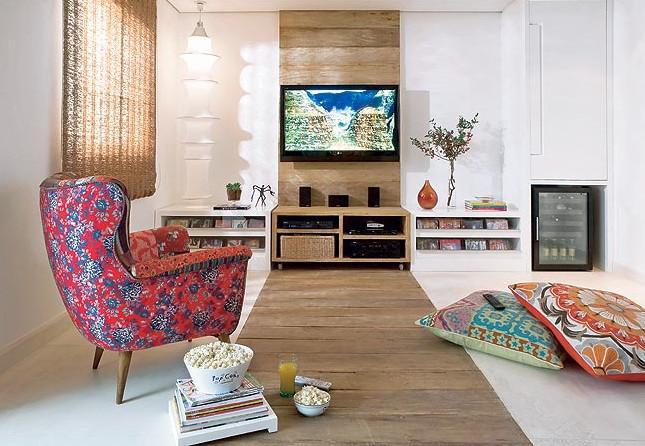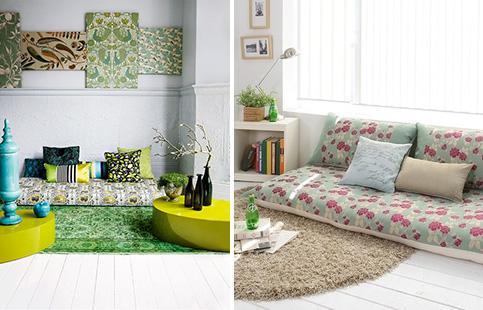The first image is the image on the left, the second image is the image on the right. Assess this claim about the two images: "An image shows a room featuring bright yellowish furniture.". Correct or not? Answer yes or no. Yes. 